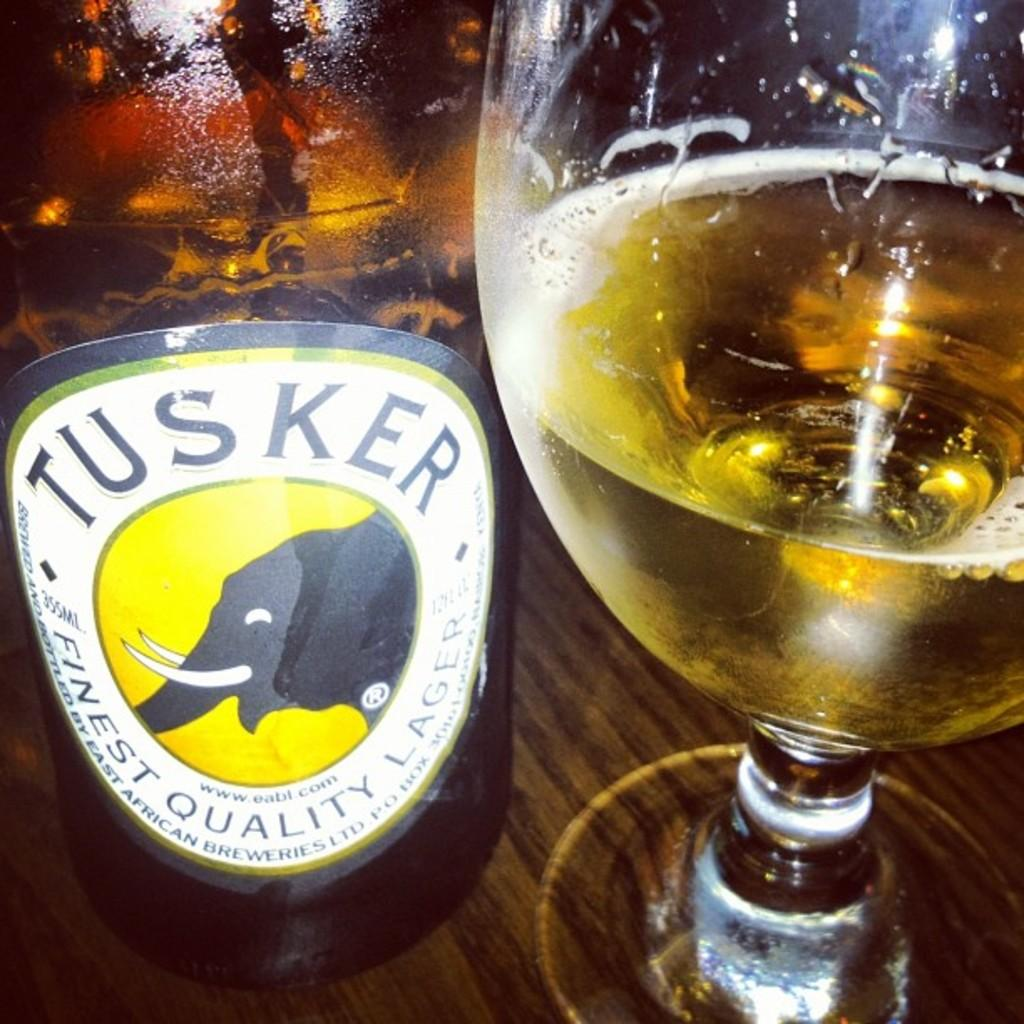What is contained in the bottle that is visible in the image? There is a bottle with liquid in the image. Can you describe any additional features of the bottle? The bottle has a sticker on it. What is the bottle placed on in the image? The bottle is on a wooden surface. What is the other glass container in the image? There is a wine glass with liquid in the image. What is unique about the contents of the wine glass? The wine glass has foam in it. Where is the wine glass located in relation to the bottle? The wine glass is beside the bottle. How many women are present in the image? There is no information about women in the image, as it only features a bottle and a wine glass. Is there a lawyer visible in the image? There is no mention of a lawyer or any legal context in the image, which only contains a bottle and a wine glass. 